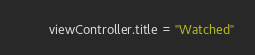<code> <loc_0><loc_0><loc_500><loc_500><_Swift_>        viewController.title = "Watched"
</code> 